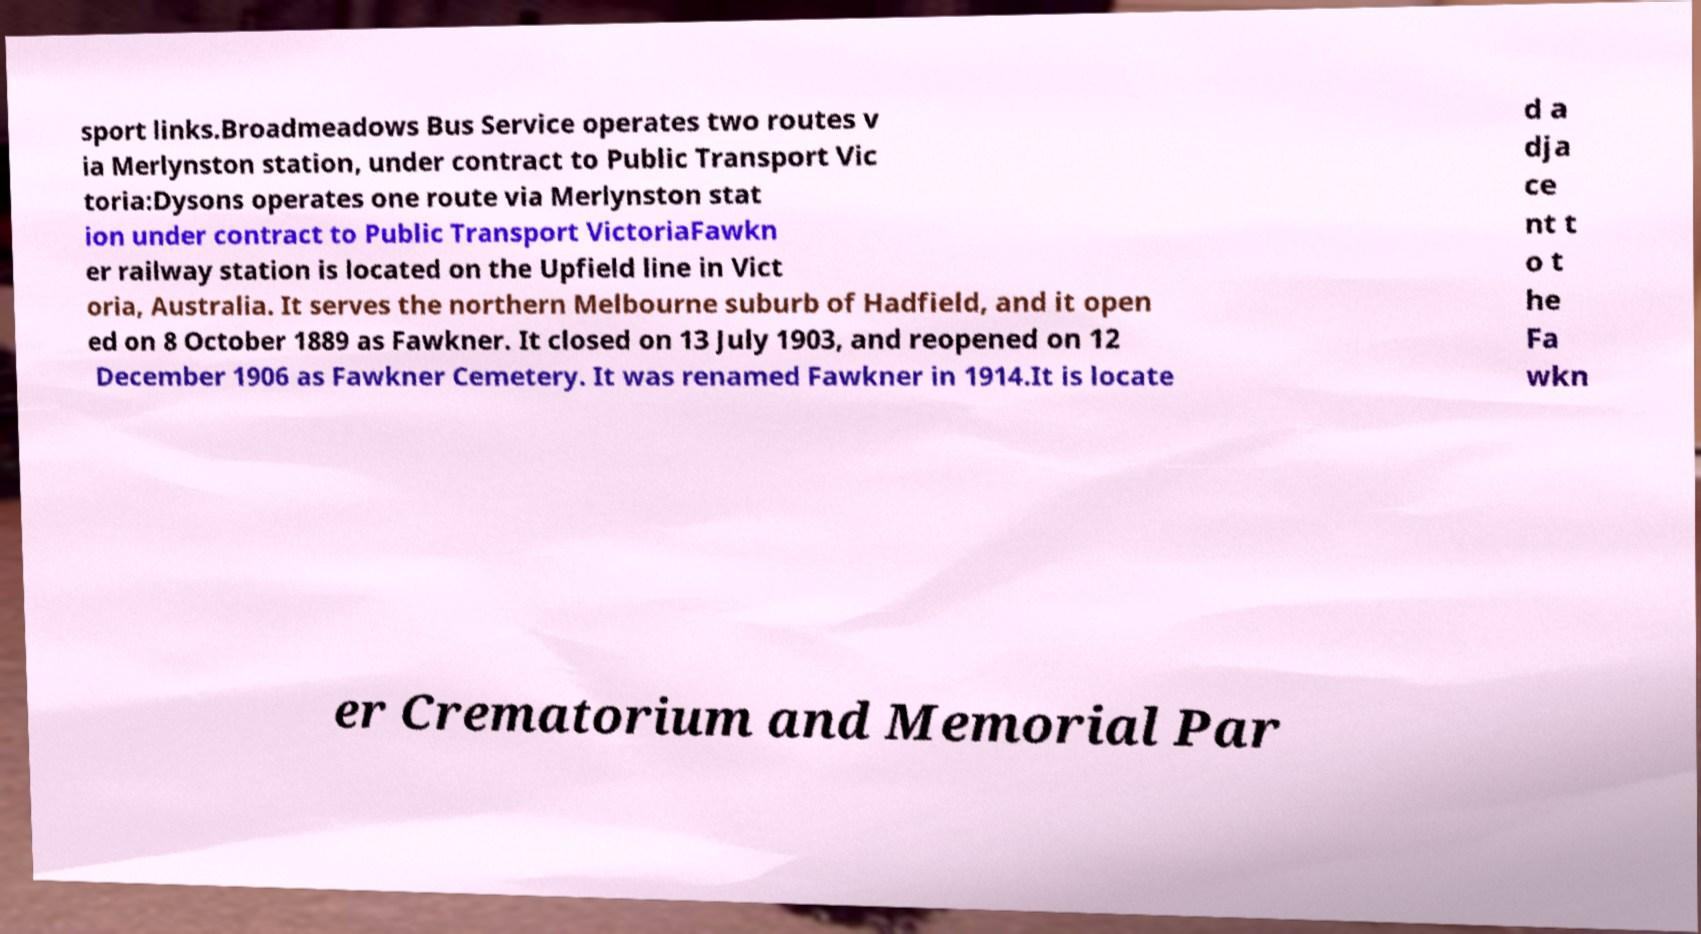Can you read and provide the text displayed in the image?This photo seems to have some interesting text. Can you extract and type it out for me? sport links.Broadmeadows Bus Service operates two routes v ia Merlynston station, under contract to Public Transport Vic toria:Dysons operates one route via Merlynston stat ion under contract to Public Transport VictoriaFawkn er railway station is located on the Upfield line in Vict oria, Australia. It serves the northern Melbourne suburb of Hadfield, and it open ed on 8 October 1889 as Fawkner. It closed on 13 July 1903, and reopened on 12 December 1906 as Fawkner Cemetery. It was renamed Fawkner in 1914.It is locate d a dja ce nt t o t he Fa wkn er Crematorium and Memorial Par 